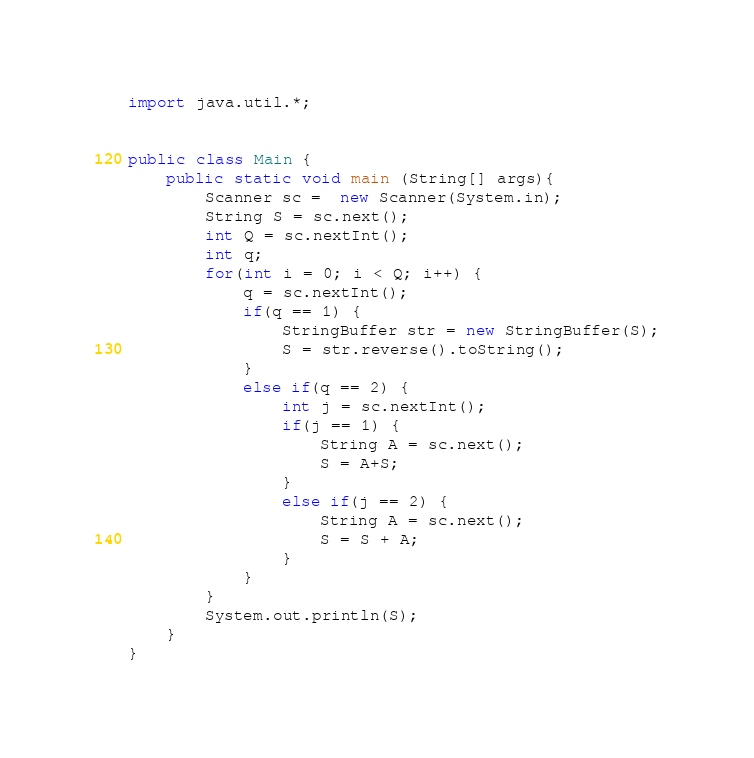Convert code to text. <code><loc_0><loc_0><loc_500><loc_500><_Java_>import java.util.*;


public class Main {
	public static void main (String[] args){
		Scanner sc =  new Scanner(System.in);
		String S = sc.next();
		int Q = sc.nextInt();
		int q;
		for(int i = 0; i < Q; i++) {
			q = sc.nextInt();
			if(q == 1) {
				StringBuffer str = new StringBuffer(S);
				S = str.reverse().toString();
			}
			else if(q == 2) {
				int j = sc.nextInt();
				if(j == 1) {				
					String A = sc.next();
					S = A+S;
				}
				else if(j == 2) {
					String A = sc.next();
					S = S + A;
				}
			}
		}
		System.out.println(S);
	}
}</code> 